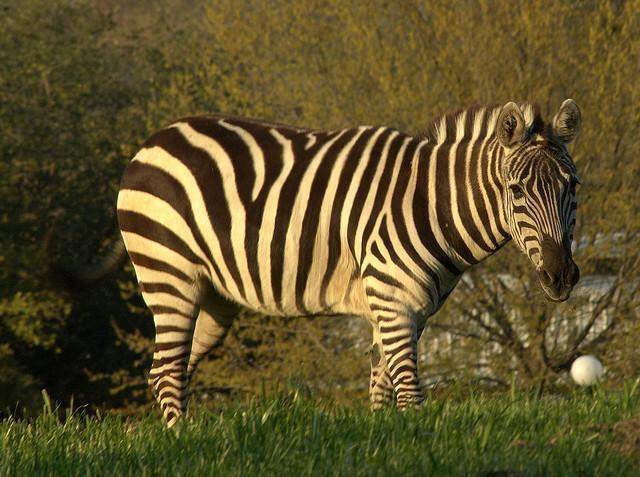How many zebras are in the photo?
Give a very brief answer. 1. How many chairs in this image are not placed at the table by the window?
Give a very brief answer. 0. 